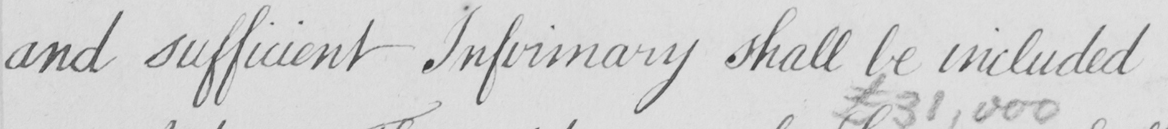Can you tell me what this handwritten text says? and sufficient Infirmary shall be included 